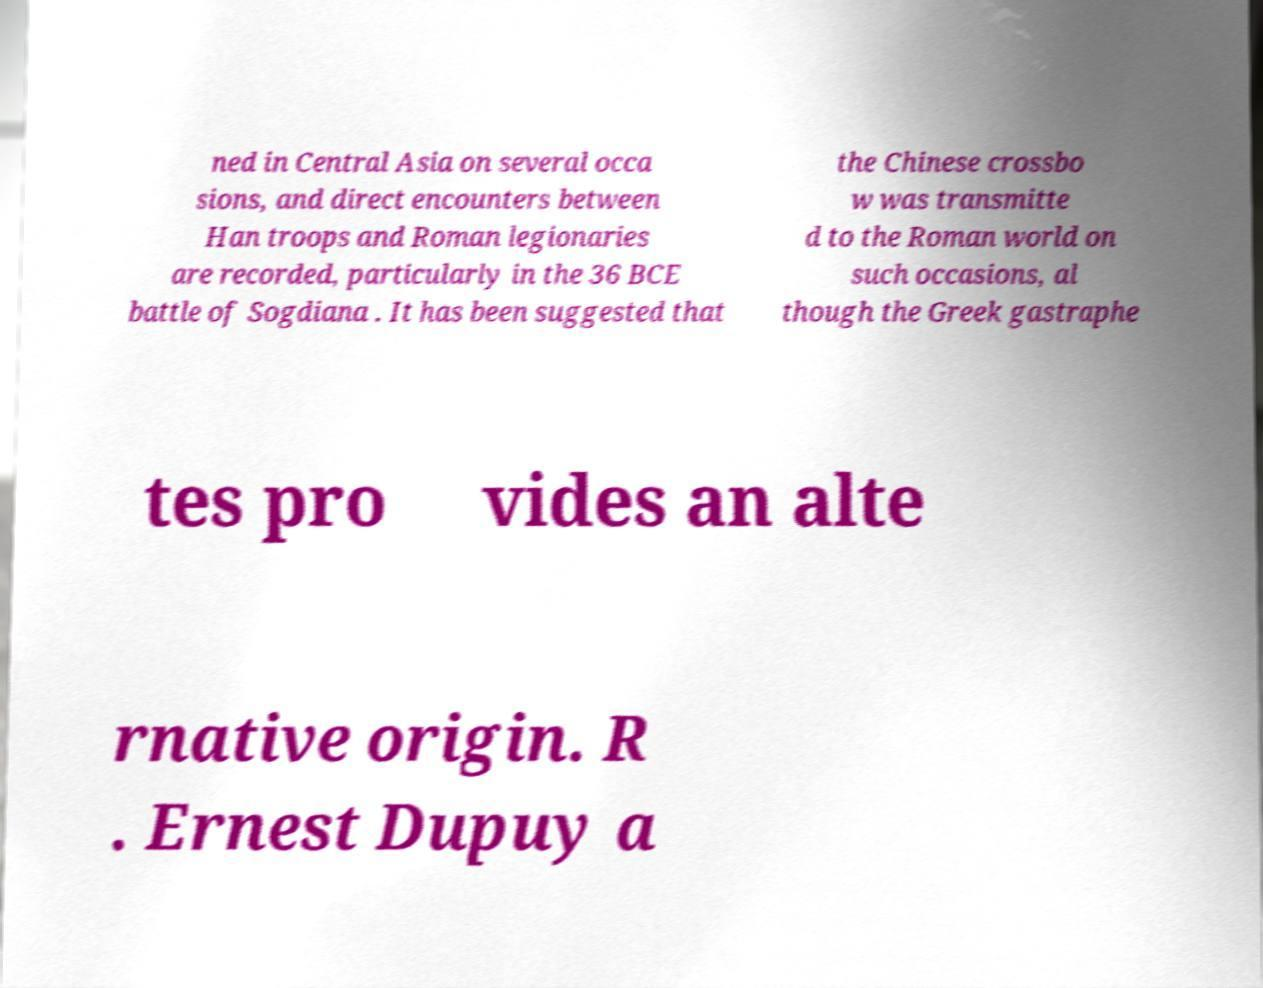Can you accurately transcribe the text from the provided image for me? ned in Central Asia on several occa sions, and direct encounters between Han troops and Roman legionaries are recorded, particularly in the 36 BCE battle of Sogdiana . It has been suggested that the Chinese crossbo w was transmitte d to the Roman world on such occasions, al though the Greek gastraphe tes pro vides an alte rnative origin. R . Ernest Dupuy a 